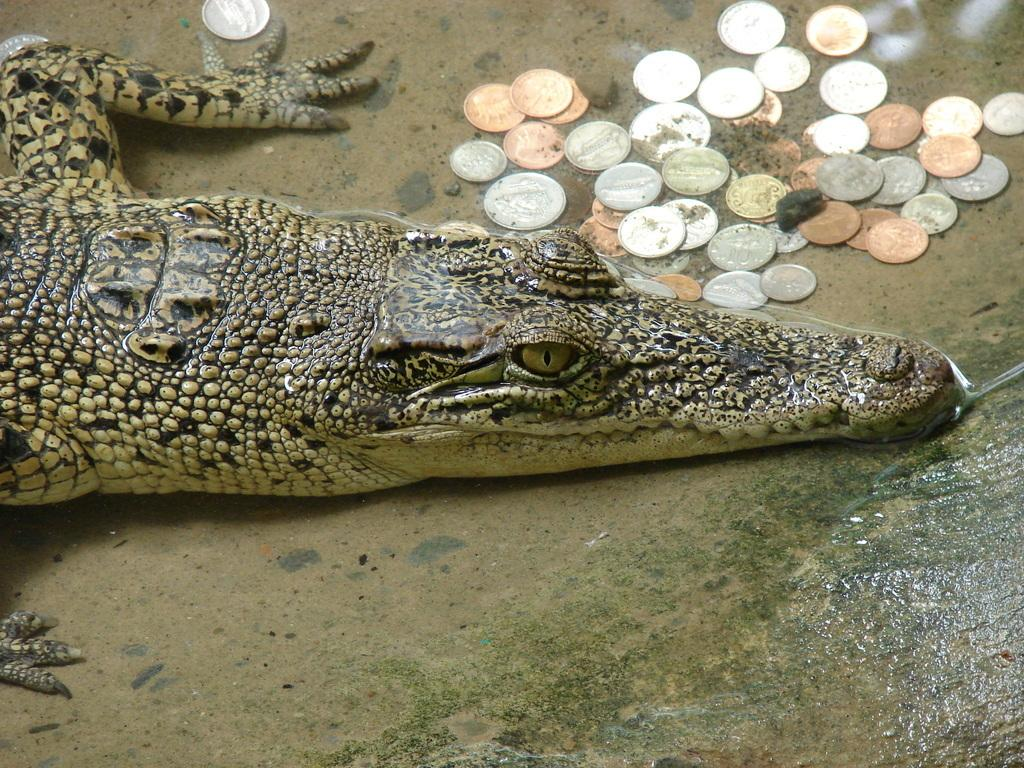What type of animal is in the image? There is a crocodile in the image. What else can be seen in the image besides the crocodile? There are coins and water visible in the image. What type of window can be seen in the image? There is no window present in the image; it features a crocodile, coins, and water. 